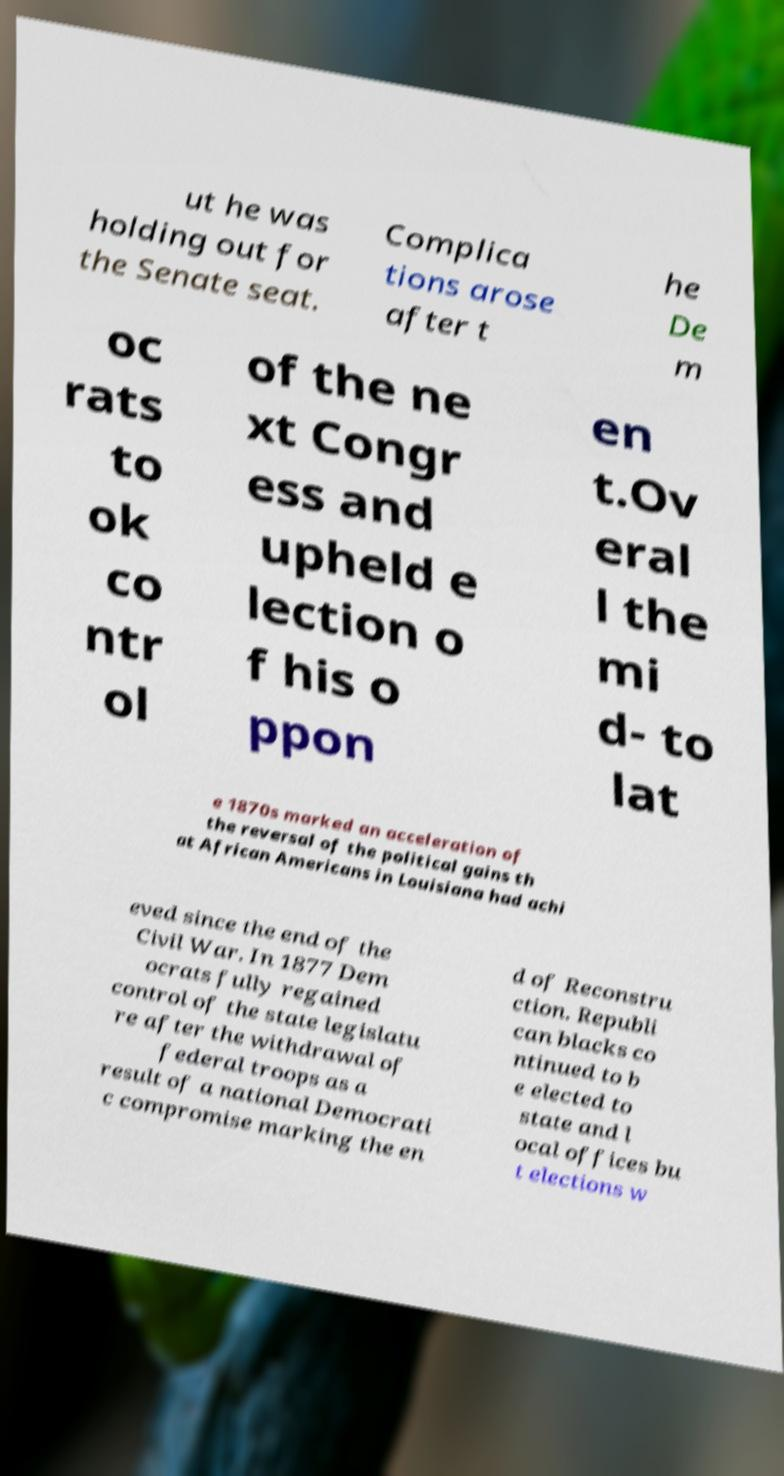Can you accurately transcribe the text from the provided image for me? ut he was holding out for the Senate seat. Complica tions arose after t he De m oc rats to ok co ntr ol of the ne xt Congr ess and upheld e lection o f his o ppon en t.Ov eral l the mi d- to lat e 1870s marked an acceleration of the reversal of the political gains th at African Americans in Louisiana had achi eved since the end of the Civil War. In 1877 Dem ocrats fully regained control of the state legislatu re after the withdrawal of federal troops as a result of a national Democrati c compromise marking the en d of Reconstru ction. Republi can blacks co ntinued to b e elected to state and l ocal offices bu t elections w 